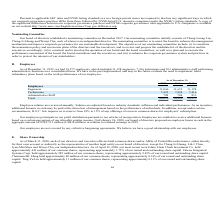According to United Micro Electronics's financial document, What is the criteria to adjust the salaries?  Salaries are adjusted based on industry standards, inflation and individual performance.. The document states: "Employee salaries are reviewed annually. Salaries are adjusted based on industry standards, inflation and individual performance. As an incentive, add..." Also, As of December 31, 2019, how many individual were employed under various departments? As of December 31, 2019, we had 19,577 employees, which included 11,328 engineers, 7,416 technicians and 833 administrative staff performing administrative functions on a consolidated basis.. The document states: "As of December 31, 2019, we had 19,577 employees, which included 11,328 engineers, 7,416 technicians and 833 administrative staff performing administr..." Also, What is the criteria for an employee to receive additional bonuses? Employees are entitled to receive additional bonuses based on a certain percentage of our allocable surplus income.. The document states: "ibution pursuant to our articles of incorporation. Employees are entitled to receive additional bonuses based on a certain percentage of our allocable..." Also, can you calculate: What are the average number of Engineers employed?  To answer this question, I need to perform calculations using the financial data. The calculation is: (11,846+11,651+11,328) / 3, which equals 11608.33 (in thousands). This is based on the information: "f December 31, 2017 2018 2019 Employees Engineers 11,846 11,651 11,328 Technicians 7,432 7,494 7,416 Administrative Staff 798 784 833 Total 20,076 19,929 19 2017 2018 2019 Employees Engineers 11,846 1..." The key data points involved are: 11,328, 11,651, 11,846. Also, can you calculate: What is the average number of Technicians employed? To answer this question, I need to perform calculations using the financial data. The calculation is: (7,432+7,494+7,416) / 3, which equals 7447.33 (in thousands). This is based on the information: "loyees Engineers 11,846 11,651 11,328 Technicians 7,432 7,494 7,416 Administrative Staff 798 784 833 Total 20,076 19,929 19,577 eers 11,846 11,651 11,328 Technicians 7,432 7,494 7,416 Administrative S..." The key data points involved are: 7,416, 7,432, 7,494. Also, can you calculate: What is the average number of Administrative Staff employed? To answer this question, I need to perform calculations using the financial data. The calculation is: (798+784+833) / 3, which equals 805. This is based on the information: "icians 7,432 7,494 7,416 Administrative Staff 798 784 833 Total 20,076 19,929 19,577 echnicians 7,432 7,494 7,416 Administrative Staff 798 784 833 Total 20,076 19,929 19,577 ns 7,432 7,494 7,416 Admin..." The key data points involved are: 784, 798, 833. 